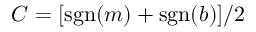Convert formula to latex. <formula><loc_0><loc_0><loc_500><loc_500>C = [ s g n ( m ) + s g n ( b ) ] / 2</formula> 